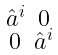Convert formula to latex. <formula><loc_0><loc_0><loc_500><loc_500>\begin{smallmatrix} \hat { a } ^ { i } & 0 \\ 0 & \hat { a } ^ { i } \end{smallmatrix}</formula> 